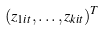Convert formula to latex. <formula><loc_0><loc_0><loc_500><loc_500>( z _ { 1 i t } , \dots , z _ { k i t } ) ^ { T }</formula> 